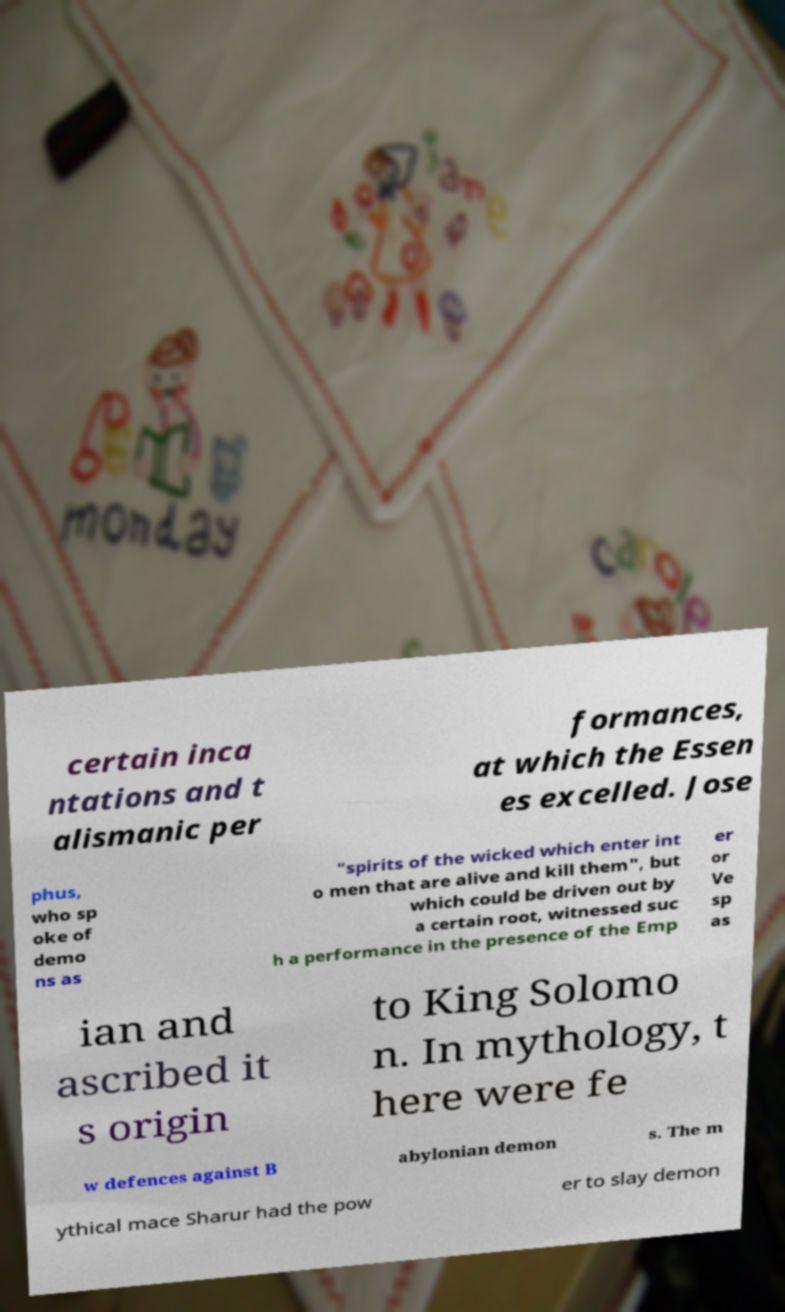I need the written content from this picture converted into text. Can you do that? certain inca ntations and t alismanic per formances, at which the Essen es excelled. Jose phus, who sp oke of demo ns as "spirits of the wicked which enter int o men that are alive and kill them", but which could be driven out by a certain root, witnessed suc h a performance in the presence of the Emp er or Ve sp as ian and ascribed it s origin to King Solomo n. In mythology, t here were fe w defences against B abylonian demon s. The m ythical mace Sharur had the pow er to slay demon 